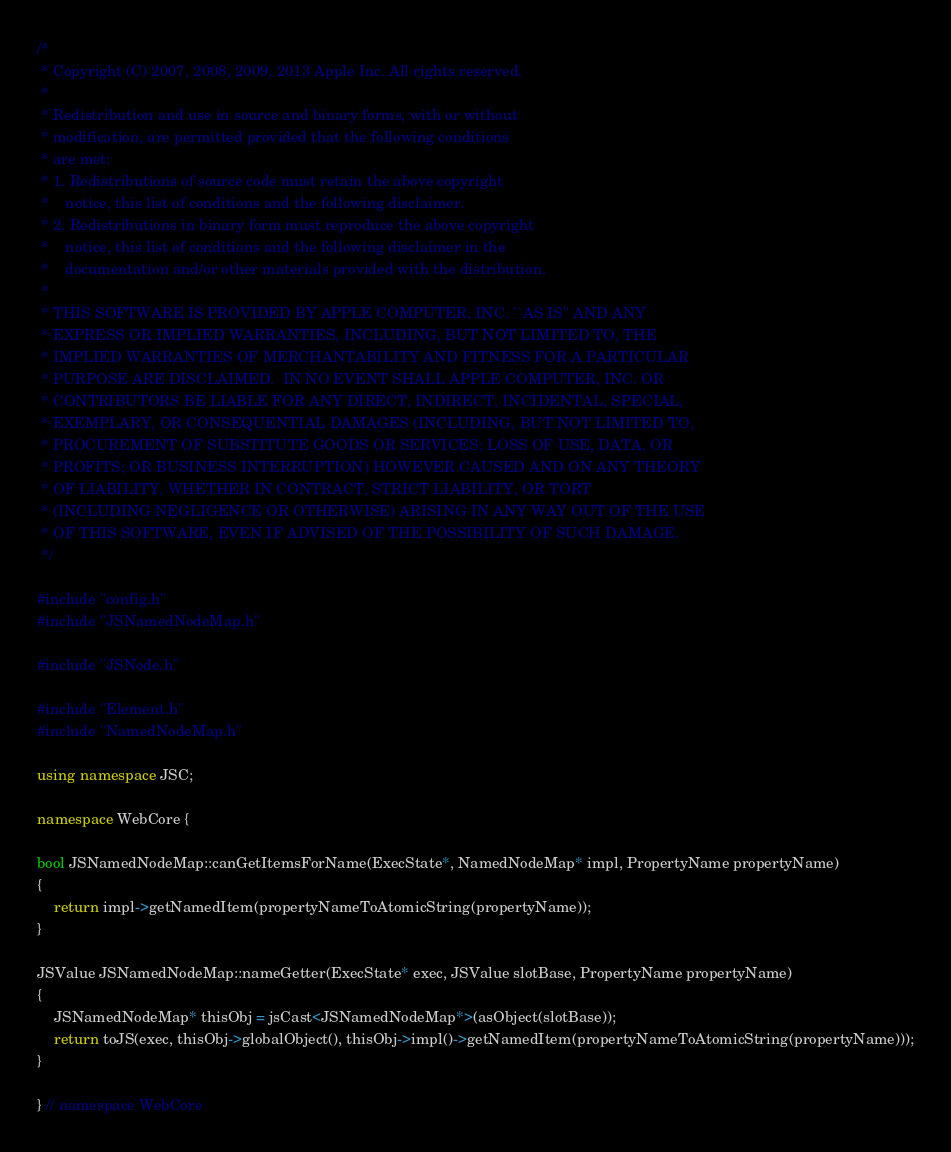<code> <loc_0><loc_0><loc_500><loc_500><_C++_>/*
 * Copyright (C) 2007, 2008, 2009, 2013 Apple Inc. All rights reserved.
 *
 * Redistribution and use in source and binary forms, with or without
 * modification, are permitted provided that the following conditions
 * are met:
 * 1. Redistributions of source code must retain the above copyright
 *    notice, this list of conditions and the following disclaimer.
 * 2. Redistributions in binary form must reproduce the above copyright
 *    notice, this list of conditions and the following disclaimer in the
 *    documentation and/or other materials provided with the distribution.
 *
 * THIS SOFTWARE IS PROVIDED BY APPLE COMPUTER, INC. ``AS IS'' AND ANY
 * EXPRESS OR IMPLIED WARRANTIES, INCLUDING, BUT NOT LIMITED TO, THE
 * IMPLIED WARRANTIES OF MERCHANTABILITY AND FITNESS FOR A PARTICULAR
 * PURPOSE ARE DISCLAIMED.  IN NO EVENT SHALL APPLE COMPUTER, INC. OR
 * CONTRIBUTORS BE LIABLE FOR ANY DIRECT, INDIRECT, INCIDENTAL, SPECIAL,
 * EXEMPLARY, OR CONSEQUENTIAL DAMAGES (INCLUDING, BUT NOT LIMITED TO,
 * PROCUREMENT OF SUBSTITUTE GOODS OR SERVICES; LOSS OF USE, DATA, OR
 * PROFITS; OR BUSINESS INTERRUPTION) HOWEVER CAUSED AND ON ANY THEORY
 * OF LIABILITY, WHETHER IN CONTRACT, STRICT LIABILITY, OR TORT
 * (INCLUDING NEGLIGENCE OR OTHERWISE) ARISING IN ANY WAY OUT OF THE USE
 * OF THIS SOFTWARE, EVEN IF ADVISED OF THE POSSIBILITY OF SUCH DAMAGE. 
 */

#include "config.h"
#include "JSNamedNodeMap.h"

#include "JSNode.h"

#include "Element.h"
#include "NamedNodeMap.h"

using namespace JSC;

namespace WebCore {

bool JSNamedNodeMap::canGetItemsForName(ExecState*, NamedNodeMap* impl, PropertyName propertyName)
{
    return impl->getNamedItem(propertyNameToAtomicString(propertyName));
}

JSValue JSNamedNodeMap::nameGetter(ExecState* exec, JSValue slotBase, PropertyName propertyName)
{
    JSNamedNodeMap* thisObj = jsCast<JSNamedNodeMap*>(asObject(slotBase));
    return toJS(exec, thisObj->globalObject(), thisObj->impl()->getNamedItem(propertyNameToAtomicString(propertyName)));
}

} // namespace WebCore
</code> 